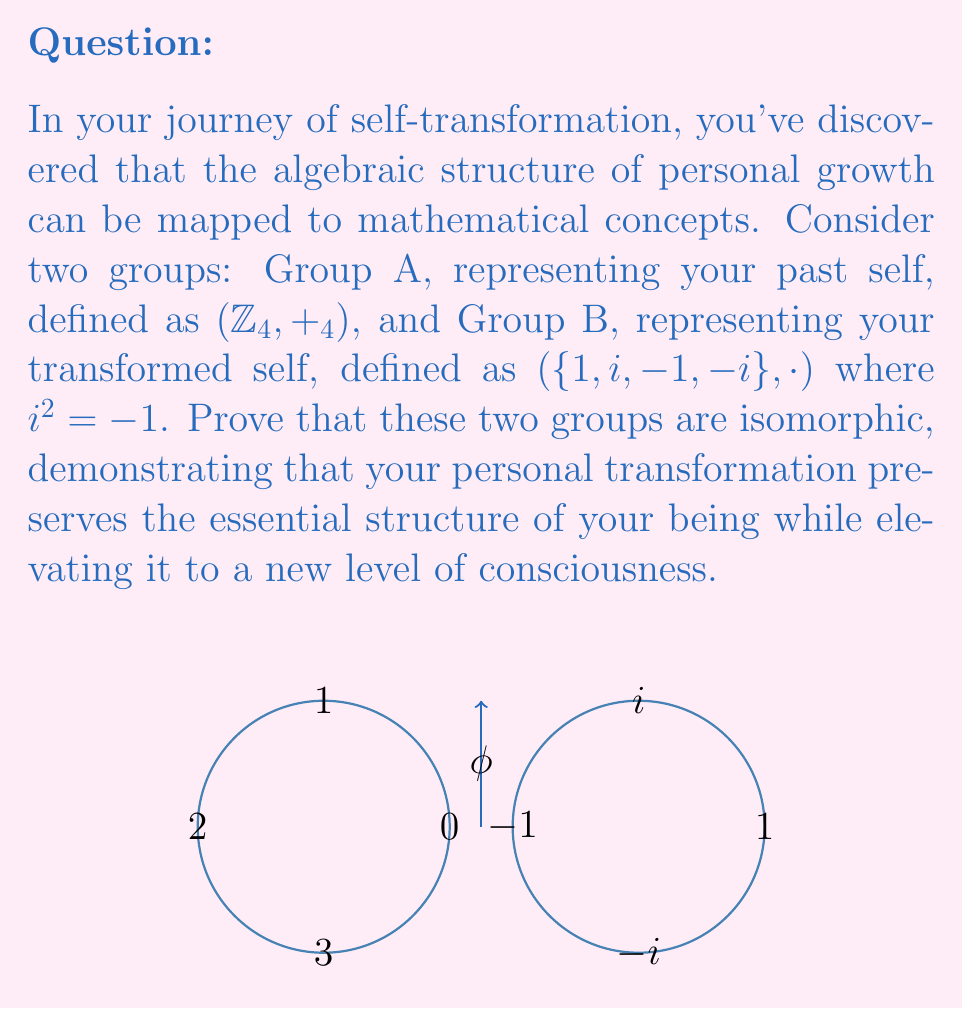Show me your answer to this math problem. To prove that the two groups are isomorphic, we need to find a bijective homomorphism $\phi$ from Group A to Group B. Let's follow these steps:

1) Define the mapping $\phi : \mathbb{Z}_4 \to \{1, i, -1, -i\}$ as follows:
   $$\phi(0) = 1, \phi(1) = i, \phi(2) = -1, \phi(3) = -i$$

2) Prove that $\phi$ is bijective:
   - It's injective (one-to-one) because each element in $\mathbb{Z}_4$ maps to a unique element in $\{1, i, -1, -i\}$.
   - It's surjective (onto) because every element in $\{1, i, -1, -i\}$ is mapped to by an element in $\mathbb{Z}_4$.

3) Prove that $\phi$ is a homomorphism:
   We need to show that for all $a, b \in \mathbb{Z}_4$, $\phi(a +_4 b) = \phi(a) \cdot \phi(b)$

   Let's check all possible combinations:
   
   $$\phi(0 +_4 0) = \phi(0) = 1 = 1 \cdot 1 = \phi(0) \cdot \phi(0)$$
   $$\phi(0 +_4 1) = \phi(1) = i = 1 \cdot i = \phi(0) \cdot \phi(1)$$
   $$\phi(0 +_4 2) = \phi(2) = -1 = 1 \cdot (-1) = \phi(0) \cdot \phi(2)$$
   $$\phi(0 +_4 3) = \phi(3) = -i = 1 \cdot (-i) = \phi(0) \cdot \phi(3)$$
   $$\phi(1 +_4 1) = \phi(2) = -1 = i \cdot i = \phi(1) \cdot \phi(1)$$
   $$\phi(1 +_4 2) = \phi(3) = -i = i \cdot (-1) = \phi(1) \cdot \phi(2)$$
   $$\phi(1 +_4 3) = \phi(0) = 1 = i \cdot (-i) = \phi(1) \cdot \phi(3)$$
   $$\phi(2 +_4 2) = \phi(0) = 1 = (-1) \cdot (-1) = \phi(2) \cdot \phi(2)$$
   $$\phi(2 +_4 3) = \phi(1) = i = (-1) \cdot (-i) = \phi(2) \cdot \phi(3)$$
   $$\phi(3 +_4 3) = \phi(2) = -1 = (-i) \cdot (-i) = \phi(3) \cdot \phi(3)$$

4) Since $\phi$ is both bijective and a homomorphism, it is an isomorphism.

Therefore, $(\mathbb{Z}_4, +_4)$ is isomorphic to $(\{1, i, -1, -i\}, \cdot)$.
Answer: $\phi(0) = 1, \phi(1) = i, \phi(2) = -1, \phi(3) = -i$ is an isomorphism. 